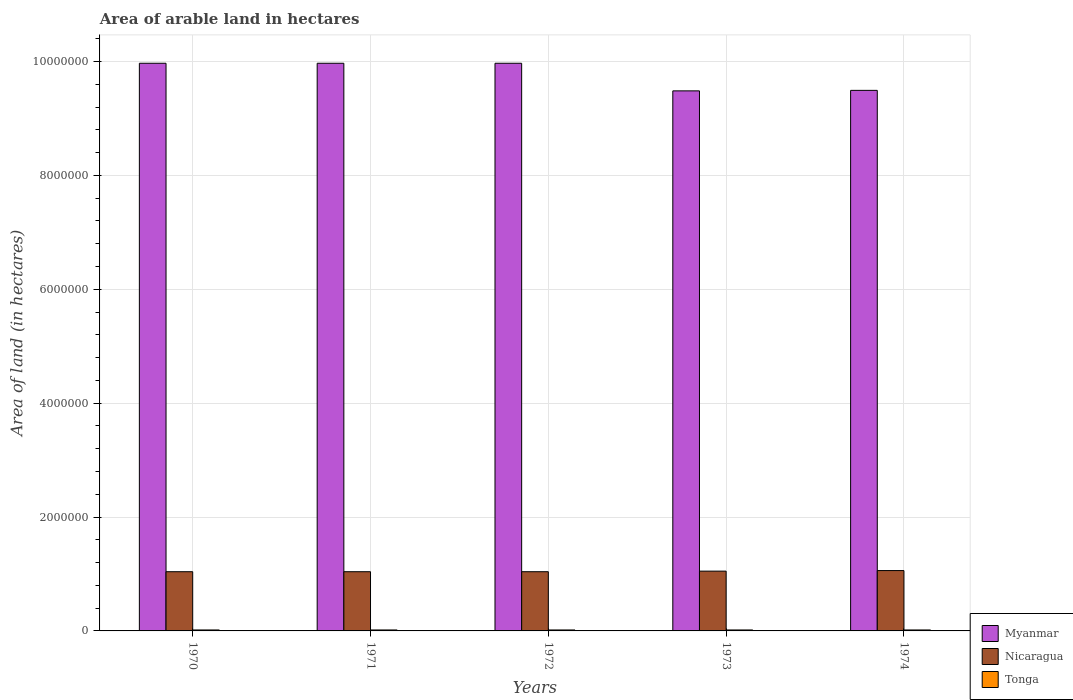How many different coloured bars are there?
Offer a terse response. 3. How many groups of bars are there?
Provide a short and direct response. 5. Are the number of bars per tick equal to the number of legend labels?
Ensure brevity in your answer.  Yes. How many bars are there on the 1st tick from the right?
Your response must be concise. 3. What is the label of the 5th group of bars from the left?
Ensure brevity in your answer.  1974. In how many cases, is the number of bars for a given year not equal to the number of legend labels?
Make the answer very short. 0. What is the total arable land in Myanmar in 1971?
Make the answer very short. 9.97e+06. Across all years, what is the maximum total arable land in Tonga?
Provide a succinct answer. 1.70e+04. Across all years, what is the minimum total arable land in Nicaragua?
Your answer should be very brief. 1.04e+06. In which year was the total arable land in Tonga minimum?
Your answer should be very brief. 1970. What is the total total arable land in Nicaragua in the graph?
Offer a very short reply. 5.23e+06. What is the difference between the total arable land in Nicaragua in 1972 and that in 1973?
Keep it short and to the point. -10000. What is the difference between the total arable land in Nicaragua in 1970 and the total arable land in Myanmar in 1974?
Offer a very short reply. -8.45e+06. What is the average total arable land in Myanmar per year?
Offer a terse response. 9.78e+06. In the year 1974, what is the difference between the total arable land in Tonga and total arable land in Myanmar?
Your response must be concise. -9.48e+06. What is the ratio of the total arable land in Myanmar in 1971 to that in 1974?
Ensure brevity in your answer.  1.05. What is the difference between the highest and the lowest total arable land in Nicaragua?
Your response must be concise. 2.00e+04. In how many years, is the total arable land in Myanmar greater than the average total arable land in Myanmar taken over all years?
Your response must be concise. 3. Is the sum of the total arable land in Myanmar in 1971 and 1974 greater than the maximum total arable land in Nicaragua across all years?
Offer a terse response. Yes. What does the 1st bar from the left in 1973 represents?
Your answer should be very brief. Myanmar. What does the 3rd bar from the right in 1971 represents?
Keep it short and to the point. Myanmar. Is it the case that in every year, the sum of the total arable land in Myanmar and total arable land in Tonga is greater than the total arable land in Nicaragua?
Your response must be concise. Yes. How many bars are there?
Provide a short and direct response. 15. What is the difference between two consecutive major ticks on the Y-axis?
Give a very brief answer. 2.00e+06. Where does the legend appear in the graph?
Your answer should be very brief. Bottom right. How many legend labels are there?
Offer a terse response. 3. What is the title of the graph?
Your answer should be compact. Area of arable land in hectares. Does "Sub-Saharan Africa (developing only)" appear as one of the legend labels in the graph?
Offer a terse response. No. What is the label or title of the X-axis?
Offer a terse response. Years. What is the label or title of the Y-axis?
Your answer should be very brief. Area of land (in hectares). What is the Area of land (in hectares) in Myanmar in 1970?
Offer a very short reply. 9.97e+06. What is the Area of land (in hectares) of Nicaragua in 1970?
Offer a terse response. 1.04e+06. What is the Area of land (in hectares) in Tonga in 1970?
Offer a terse response. 1.70e+04. What is the Area of land (in hectares) in Myanmar in 1971?
Keep it short and to the point. 9.97e+06. What is the Area of land (in hectares) in Nicaragua in 1971?
Your answer should be very brief. 1.04e+06. What is the Area of land (in hectares) in Tonga in 1971?
Your answer should be very brief. 1.70e+04. What is the Area of land (in hectares) of Myanmar in 1972?
Your answer should be very brief. 9.97e+06. What is the Area of land (in hectares) in Nicaragua in 1972?
Your answer should be very brief. 1.04e+06. What is the Area of land (in hectares) in Tonga in 1972?
Provide a short and direct response. 1.70e+04. What is the Area of land (in hectares) of Myanmar in 1973?
Ensure brevity in your answer.  9.48e+06. What is the Area of land (in hectares) in Nicaragua in 1973?
Make the answer very short. 1.05e+06. What is the Area of land (in hectares) of Tonga in 1973?
Your answer should be compact. 1.70e+04. What is the Area of land (in hectares) of Myanmar in 1974?
Keep it short and to the point. 9.49e+06. What is the Area of land (in hectares) of Nicaragua in 1974?
Offer a terse response. 1.06e+06. What is the Area of land (in hectares) of Tonga in 1974?
Keep it short and to the point. 1.70e+04. Across all years, what is the maximum Area of land (in hectares) in Myanmar?
Your answer should be compact. 9.97e+06. Across all years, what is the maximum Area of land (in hectares) of Nicaragua?
Ensure brevity in your answer.  1.06e+06. Across all years, what is the maximum Area of land (in hectares) of Tonga?
Your answer should be compact. 1.70e+04. Across all years, what is the minimum Area of land (in hectares) in Myanmar?
Ensure brevity in your answer.  9.48e+06. Across all years, what is the minimum Area of land (in hectares) of Nicaragua?
Provide a succinct answer. 1.04e+06. Across all years, what is the minimum Area of land (in hectares) of Tonga?
Ensure brevity in your answer.  1.70e+04. What is the total Area of land (in hectares) in Myanmar in the graph?
Offer a very short reply. 4.89e+07. What is the total Area of land (in hectares) in Nicaragua in the graph?
Make the answer very short. 5.23e+06. What is the total Area of land (in hectares) of Tonga in the graph?
Ensure brevity in your answer.  8.50e+04. What is the difference between the Area of land (in hectares) of Myanmar in 1970 and that in 1971?
Your response must be concise. 0. What is the difference between the Area of land (in hectares) in Tonga in 1970 and that in 1971?
Ensure brevity in your answer.  0. What is the difference between the Area of land (in hectares) in Tonga in 1970 and that in 1972?
Offer a very short reply. 0. What is the difference between the Area of land (in hectares) in Myanmar in 1970 and that in 1973?
Ensure brevity in your answer.  4.85e+05. What is the difference between the Area of land (in hectares) of Tonga in 1970 and that in 1973?
Offer a terse response. 0. What is the difference between the Area of land (in hectares) in Myanmar in 1970 and that in 1974?
Offer a very short reply. 4.76e+05. What is the difference between the Area of land (in hectares) in Nicaragua in 1970 and that in 1974?
Provide a short and direct response. -2.00e+04. What is the difference between the Area of land (in hectares) of Nicaragua in 1971 and that in 1972?
Your answer should be very brief. 0. What is the difference between the Area of land (in hectares) of Tonga in 1971 and that in 1972?
Make the answer very short. 0. What is the difference between the Area of land (in hectares) of Myanmar in 1971 and that in 1973?
Your answer should be compact. 4.85e+05. What is the difference between the Area of land (in hectares) in Nicaragua in 1971 and that in 1973?
Offer a very short reply. -10000. What is the difference between the Area of land (in hectares) in Myanmar in 1971 and that in 1974?
Your response must be concise. 4.76e+05. What is the difference between the Area of land (in hectares) in Myanmar in 1972 and that in 1973?
Provide a short and direct response. 4.85e+05. What is the difference between the Area of land (in hectares) of Tonga in 1972 and that in 1973?
Offer a terse response. 0. What is the difference between the Area of land (in hectares) in Myanmar in 1972 and that in 1974?
Your answer should be compact. 4.76e+05. What is the difference between the Area of land (in hectares) in Myanmar in 1973 and that in 1974?
Offer a terse response. -9000. What is the difference between the Area of land (in hectares) of Tonga in 1973 and that in 1974?
Ensure brevity in your answer.  0. What is the difference between the Area of land (in hectares) in Myanmar in 1970 and the Area of land (in hectares) in Nicaragua in 1971?
Provide a succinct answer. 8.93e+06. What is the difference between the Area of land (in hectares) in Myanmar in 1970 and the Area of land (in hectares) in Tonga in 1971?
Your answer should be very brief. 9.95e+06. What is the difference between the Area of land (in hectares) of Nicaragua in 1970 and the Area of land (in hectares) of Tonga in 1971?
Make the answer very short. 1.02e+06. What is the difference between the Area of land (in hectares) of Myanmar in 1970 and the Area of land (in hectares) of Nicaragua in 1972?
Your answer should be very brief. 8.93e+06. What is the difference between the Area of land (in hectares) of Myanmar in 1970 and the Area of land (in hectares) of Tonga in 1972?
Give a very brief answer. 9.95e+06. What is the difference between the Area of land (in hectares) in Nicaragua in 1970 and the Area of land (in hectares) in Tonga in 1972?
Offer a very short reply. 1.02e+06. What is the difference between the Area of land (in hectares) in Myanmar in 1970 and the Area of land (in hectares) in Nicaragua in 1973?
Ensure brevity in your answer.  8.92e+06. What is the difference between the Area of land (in hectares) of Myanmar in 1970 and the Area of land (in hectares) of Tonga in 1973?
Your response must be concise. 9.95e+06. What is the difference between the Area of land (in hectares) in Nicaragua in 1970 and the Area of land (in hectares) in Tonga in 1973?
Your response must be concise. 1.02e+06. What is the difference between the Area of land (in hectares) in Myanmar in 1970 and the Area of land (in hectares) in Nicaragua in 1974?
Your answer should be very brief. 8.91e+06. What is the difference between the Area of land (in hectares) in Myanmar in 1970 and the Area of land (in hectares) in Tonga in 1974?
Provide a short and direct response. 9.95e+06. What is the difference between the Area of land (in hectares) of Nicaragua in 1970 and the Area of land (in hectares) of Tonga in 1974?
Provide a short and direct response. 1.02e+06. What is the difference between the Area of land (in hectares) of Myanmar in 1971 and the Area of land (in hectares) of Nicaragua in 1972?
Ensure brevity in your answer.  8.93e+06. What is the difference between the Area of land (in hectares) of Myanmar in 1971 and the Area of land (in hectares) of Tonga in 1972?
Offer a terse response. 9.95e+06. What is the difference between the Area of land (in hectares) of Nicaragua in 1971 and the Area of land (in hectares) of Tonga in 1972?
Your answer should be compact. 1.02e+06. What is the difference between the Area of land (in hectares) in Myanmar in 1971 and the Area of land (in hectares) in Nicaragua in 1973?
Keep it short and to the point. 8.92e+06. What is the difference between the Area of land (in hectares) of Myanmar in 1971 and the Area of land (in hectares) of Tonga in 1973?
Give a very brief answer. 9.95e+06. What is the difference between the Area of land (in hectares) of Nicaragua in 1971 and the Area of land (in hectares) of Tonga in 1973?
Provide a succinct answer. 1.02e+06. What is the difference between the Area of land (in hectares) of Myanmar in 1971 and the Area of land (in hectares) of Nicaragua in 1974?
Provide a short and direct response. 8.91e+06. What is the difference between the Area of land (in hectares) of Myanmar in 1971 and the Area of land (in hectares) of Tonga in 1974?
Your answer should be very brief. 9.95e+06. What is the difference between the Area of land (in hectares) of Nicaragua in 1971 and the Area of land (in hectares) of Tonga in 1974?
Your response must be concise. 1.02e+06. What is the difference between the Area of land (in hectares) in Myanmar in 1972 and the Area of land (in hectares) in Nicaragua in 1973?
Make the answer very short. 8.92e+06. What is the difference between the Area of land (in hectares) in Myanmar in 1972 and the Area of land (in hectares) in Tonga in 1973?
Provide a short and direct response. 9.95e+06. What is the difference between the Area of land (in hectares) of Nicaragua in 1972 and the Area of land (in hectares) of Tonga in 1973?
Give a very brief answer. 1.02e+06. What is the difference between the Area of land (in hectares) of Myanmar in 1972 and the Area of land (in hectares) of Nicaragua in 1974?
Give a very brief answer. 8.91e+06. What is the difference between the Area of land (in hectares) of Myanmar in 1972 and the Area of land (in hectares) of Tonga in 1974?
Your answer should be compact. 9.95e+06. What is the difference between the Area of land (in hectares) in Nicaragua in 1972 and the Area of land (in hectares) in Tonga in 1974?
Provide a succinct answer. 1.02e+06. What is the difference between the Area of land (in hectares) in Myanmar in 1973 and the Area of land (in hectares) in Nicaragua in 1974?
Your response must be concise. 8.42e+06. What is the difference between the Area of land (in hectares) in Myanmar in 1973 and the Area of land (in hectares) in Tonga in 1974?
Give a very brief answer. 9.47e+06. What is the difference between the Area of land (in hectares) of Nicaragua in 1973 and the Area of land (in hectares) of Tonga in 1974?
Offer a very short reply. 1.03e+06. What is the average Area of land (in hectares) of Myanmar per year?
Keep it short and to the point. 9.78e+06. What is the average Area of land (in hectares) of Nicaragua per year?
Offer a very short reply. 1.05e+06. What is the average Area of land (in hectares) of Tonga per year?
Offer a very short reply. 1.70e+04. In the year 1970, what is the difference between the Area of land (in hectares) in Myanmar and Area of land (in hectares) in Nicaragua?
Your answer should be very brief. 8.93e+06. In the year 1970, what is the difference between the Area of land (in hectares) in Myanmar and Area of land (in hectares) in Tonga?
Your answer should be compact. 9.95e+06. In the year 1970, what is the difference between the Area of land (in hectares) in Nicaragua and Area of land (in hectares) in Tonga?
Make the answer very short. 1.02e+06. In the year 1971, what is the difference between the Area of land (in hectares) of Myanmar and Area of land (in hectares) of Nicaragua?
Your answer should be compact. 8.93e+06. In the year 1971, what is the difference between the Area of land (in hectares) in Myanmar and Area of land (in hectares) in Tonga?
Provide a short and direct response. 9.95e+06. In the year 1971, what is the difference between the Area of land (in hectares) in Nicaragua and Area of land (in hectares) in Tonga?
Offer a very short reply. 1.02e+06. In the year 1972, what is the difference between the Area of land (in hectares) of Myanmar and Area of land (in hectares) of Nicaragua?
Your answer should be very brief. 8.93e+06. In the year 1972, what is the difference between the Area of land (in hectares) in Myanmar and Area of land (in hectares) in Tonga?
Offer a terse response. 9.95e+06. In the year 1972, what is the difference between the Area of land (in hectares) of Nicaragua and Area of land (in hectares) of Tonga?
Offer a very short reply. 1.02e+06. In the year 1973, what is the difference between the Area of land (in hectares) in Myanmar and Area of land (in hectares) in Nicaragua?
Your answer should be compact. 8.44e+06. In the year 1973, what is the difference between the Area of land (in hectares) of Myanmar and Area of land (in hectares) of Tonga?
Offer a very short reply. 9.47e+06. In the year 1973, what is the difference between the Area of land (in hectares) in Nicaragua and Area of land (in hectares) in Tonga?
Your answer should be compact. 1.03e+06. In the year 1974, what is the difference between the Area of land (in hectares) in Myanmar and Area of land (in hectares) in Nicaragua?
Your answer should be very brief. 8.43e+06. In the year 1974, what is the difference between the Area of land (in hectares) in Myanmar and Area of land (in hectares) in Tonga?
Make the answer very short. 9.48e+06. In the year 1974, what is the difference between the Area of land (in hectares) in Nicaragua and Area of land (in hectares) in Tonga?
Your answer should be very brief. 1.04e+06. What is the ratio of the Area of land (in hectares) in Tonga in 1970 to that in 1971?
Make the answer very short. 1. What is the ratio of the Area of land (in hectares) in Nicaragua in 1970 to that in 1972?
Offer a terse response. 1. What is the ratio of the Area of land (in hectares) of Myanmar in 1970 to that in 1973?
Your answer should be very brief. 1.05. What is the ratio of the Area of land (in hectares) of Nicaragua in 1970 to that in 1973?
Provide a short and direct response. 0.99. What is the ratio of the Area of land (in hectares) of Myanmar in 1970 to that in 1974?
Offer a terse response. 1.05. What is the ratio of the Area of land (in hectares) in Nicaragua in 1970 to that in 1974?
Ensure brevity in your answer.  0.98. What is the ratio of the Area of land (in hectares) in Myanmar in 1971 to that in 1972?
Provide a succinct answer. 1. What is the ratio of the Area of land (in hectares) of Tonga in 1971 to that in 1972?
Your answer should be compact. 1. What is the ratio of the Area of land (in hectares) in Myanmar in 1971 to that in 1973?
Your response must be concise. 1.05. What is the ratio of the Area of land (in hectares) in Nicaragua in 1971 to that in 1973?
Provide a succinct answer. 0.99. What is the ratio of the Area of land (in hectares) in Myanmar in 1971 to that in 1974?
Your answer should be very brief. 1.05. What is the ratio of the Area of land (in hectares) of Nicaragua in 1971 to that in 1974?
Your answer should be compact. 0.98. What is the ratio of the Area of land (in hectares) in Tonga in 1971 to that in 1974?
Keep it short and to the point. 1. What is the ratio of the Area of land (in hectares) in Myanmar in 1972 to that in 1973?
Your answer should be very brief. 1.05. What is the ratio of the Area of land (in hectares) in Tonga in 1972 to that in 1973?
Offer a terse response. 1. What is the ratio of the Area of land (in hectares) of Myanmar in 1972 to that in 1974?
Offer a very short reply. 1.05. What is the ratio of the Area of land (in hectares) in Nicaragua in 1972 to that in 1974?
Provide a short and direct response. 0.98. What is the ratio of the Area of land (in hectares) in Tonga in 1972 to that in 1974?
Your answer should be very brief. 1. What is the ratio of the Area of land (in hectares) in Myanmar in 1973 to that in 1974?
Your response must be concise. 1. What is the ratio of the Area of land (in hectares) of Nicaragua in 1973 to that in 1974?
Your answer should be compact. 0.99. What is the ratio of the Area of land (in hectares) of Tonga in 1973 to that in 1974?
Your response must be concise. 1. What is the difference between the highest and the second highest Area of land (in hectares) of Myanmar?
Give a very brief answer. 0. What is the difference between the highest and the second highest Area of land (in hectares) in Nicaragua?
Give a very brief answer. 10000. What is the difference between the highest and the second highest Area of land (in hectares) of Tonga?
Keep it short and to the point. 0. What is the difference between the highest and the lowest Area of land (in hectares) of Myanmar?
Your answer should be very brief. 4.85e+05. What is the difference between the highest and the lowest Area of land (in hectares) of Nicaragua?
Offer a terse response. 2.00e+04. What is the difference between the highest and the lowest Area of land (in hectares) of Tonga?
Provide a short and direct response. 0. 